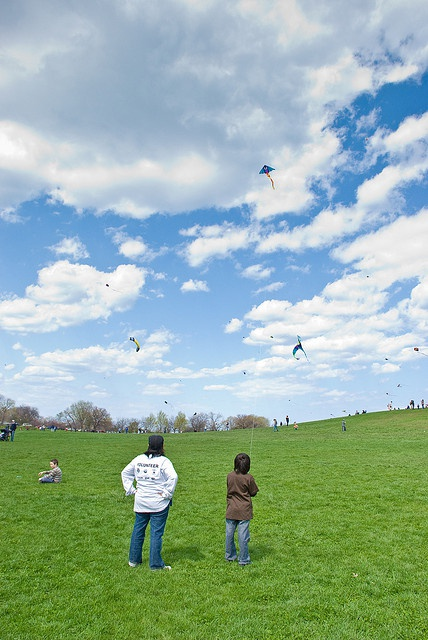Describe the objects in this image and their specific colors. I can see people in darkgray, white, blue, black, and darkblue tones, people in darkgray, gray, black, darkgreen, and blue tones, people in darkgray, gray, lightgray, and green tones, kite in darkgray, teal, lavender, and navy tones, and kite in darkgray, lightgray, lightblue, and teal tones in this image. 